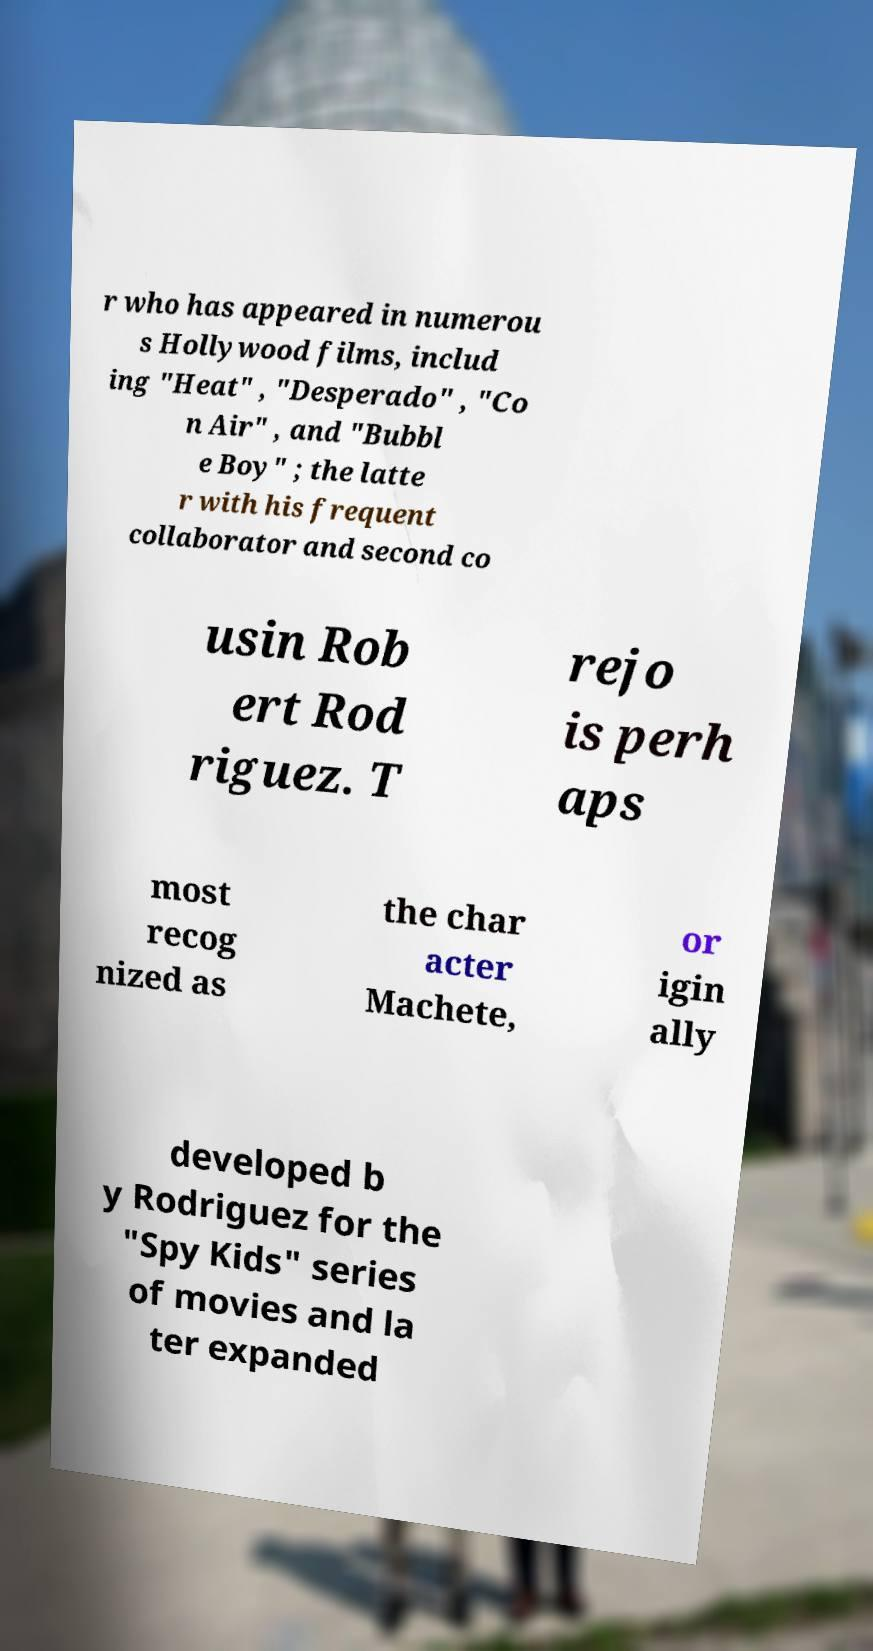I need the written content from this picture converted into text. Can you do that? r who has appeared in numerou s Hollywood films, includ ing "Heat" , "Desperado" , "Co n Air" , and "Bubbl e Boy" ; the latte r with his frequent collaborator and second co usin Rob ert Rod riguez. T rejo is perh aps most recog nized as the char acter Machete, or igin ally developed b y Rodriguez for the "Spy Kids" series of movies and la ter expanded 